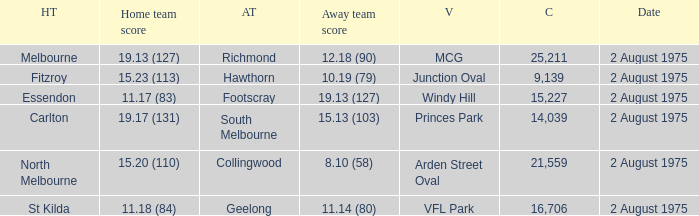When was a game played where the away team scored 10.19 (79)? 2 August 1975. 